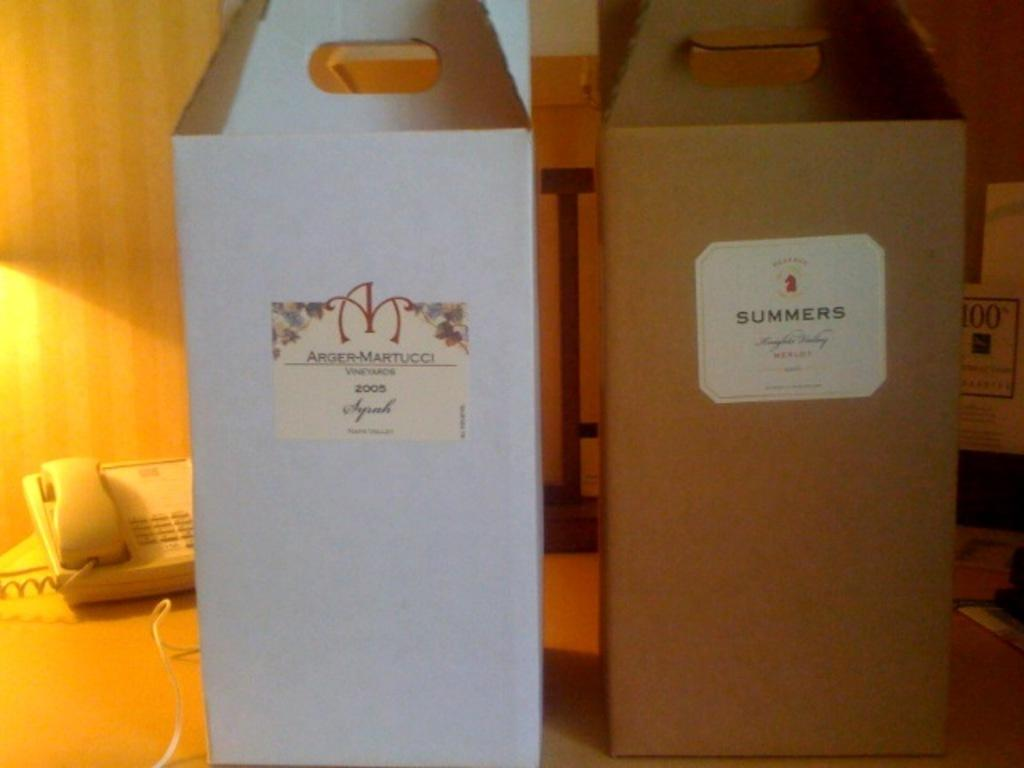<image>
Give a short and clear explanation of the subsequent image. Two cardboard boxes that look like they hold bottles in them with one saying Summers on it. 